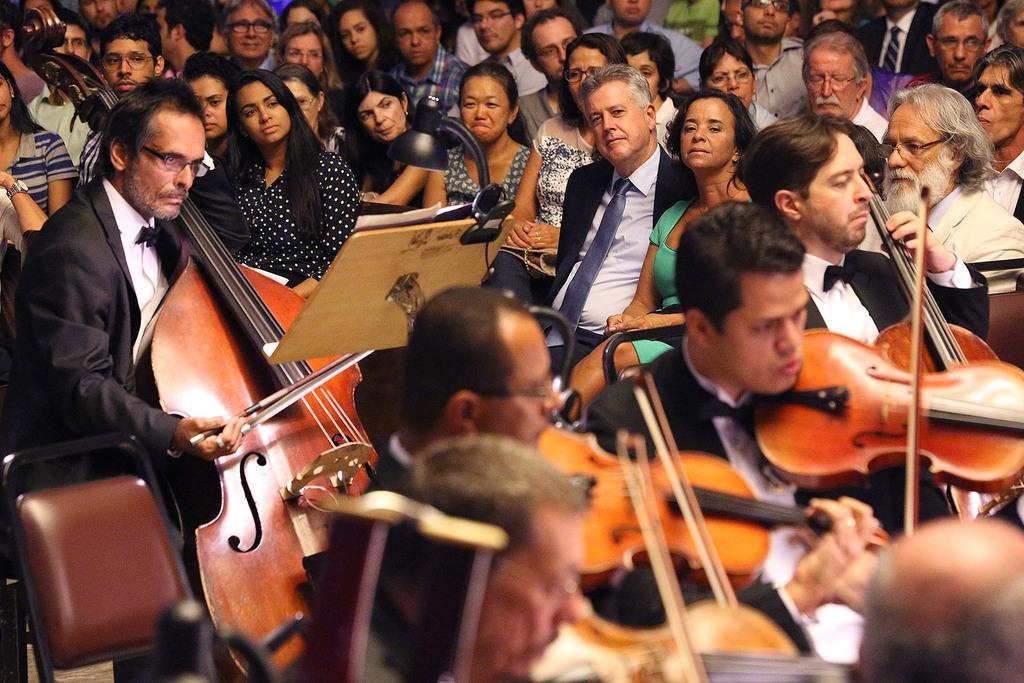How would you summarize this image in a sentence or two? In this image I can see number of people are sitting. I can also see few of them are holding musical Instruments. Here I can see a chair and a lamp. 